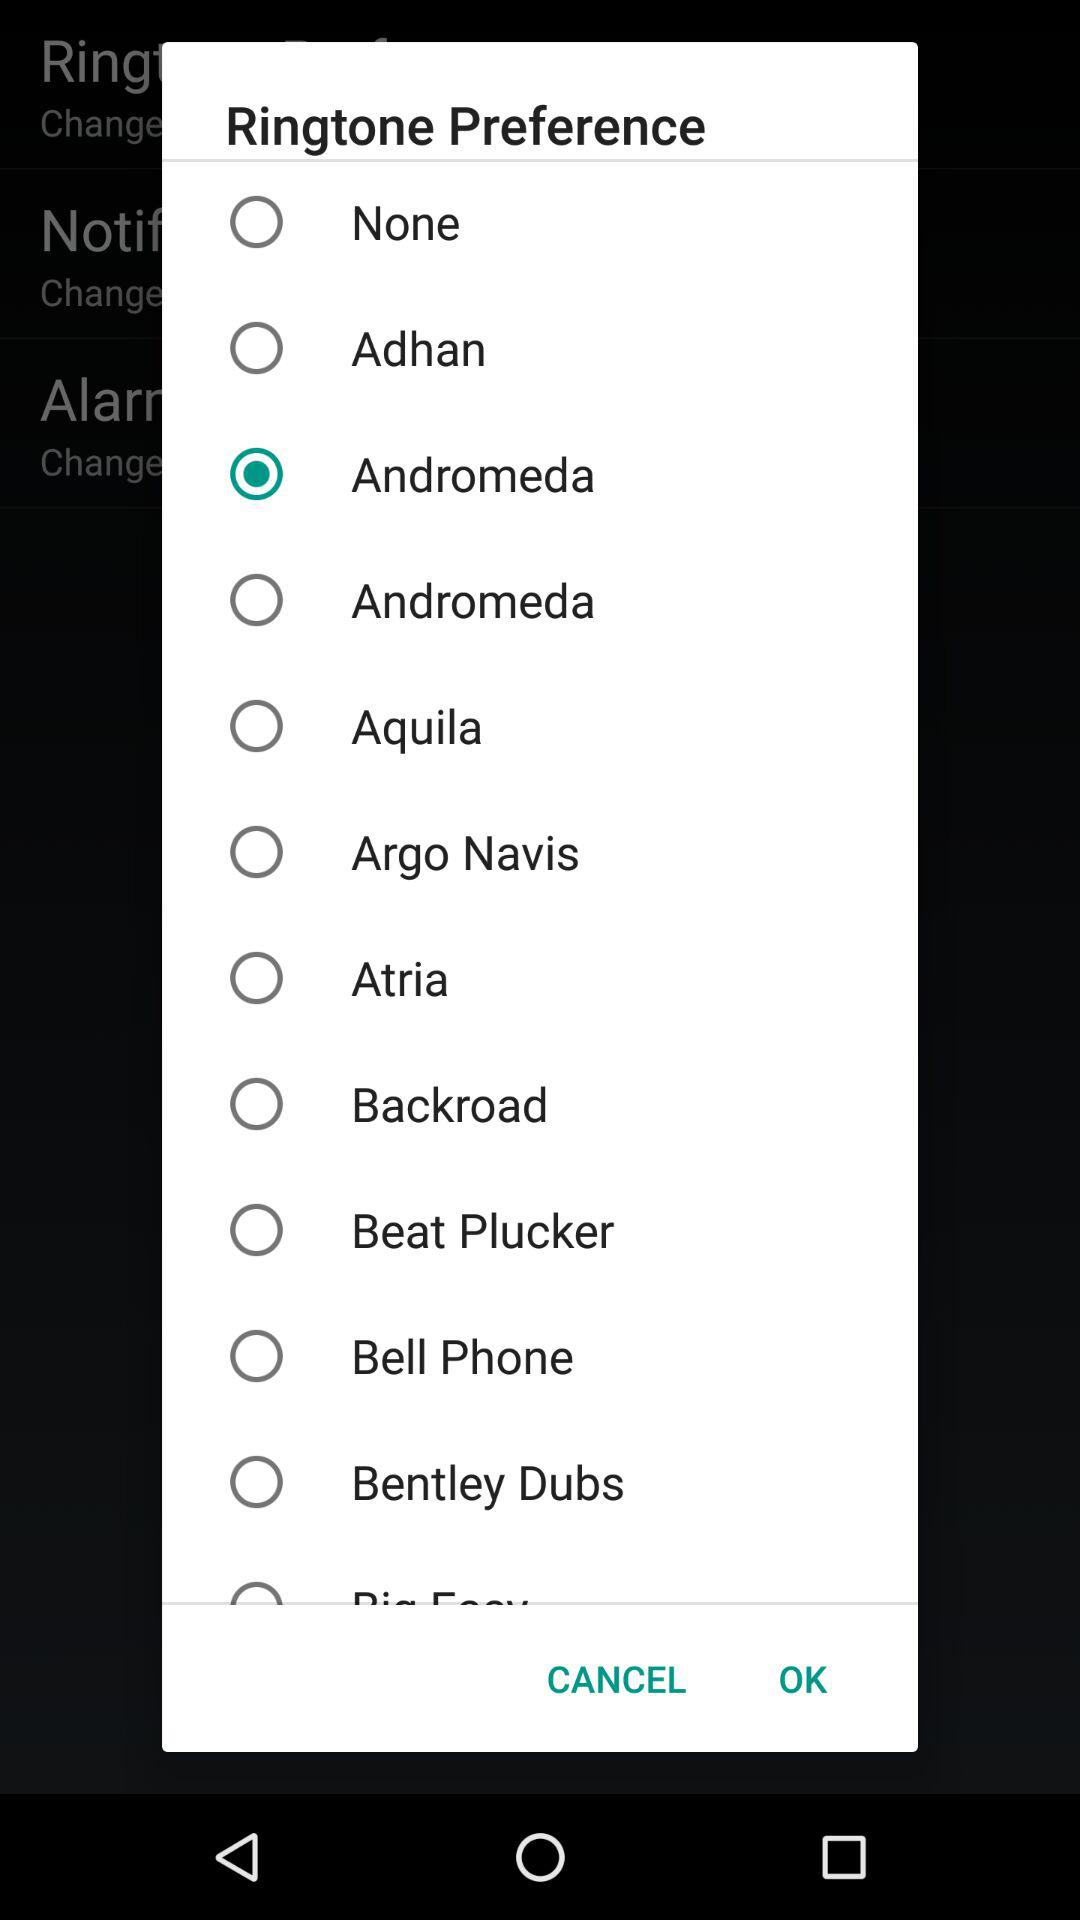What is the selected ringtone? The selected ringtone is "Andromeda". 